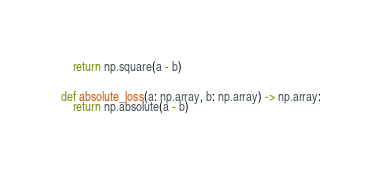<code> <loc_0><loc_0><loc_500><loc_500><_Python_>    return np.square(a - b)


def absolute_loss(a: np.array, b: np.array) -> np.array:
    return np.absolute(a - b)</code> 